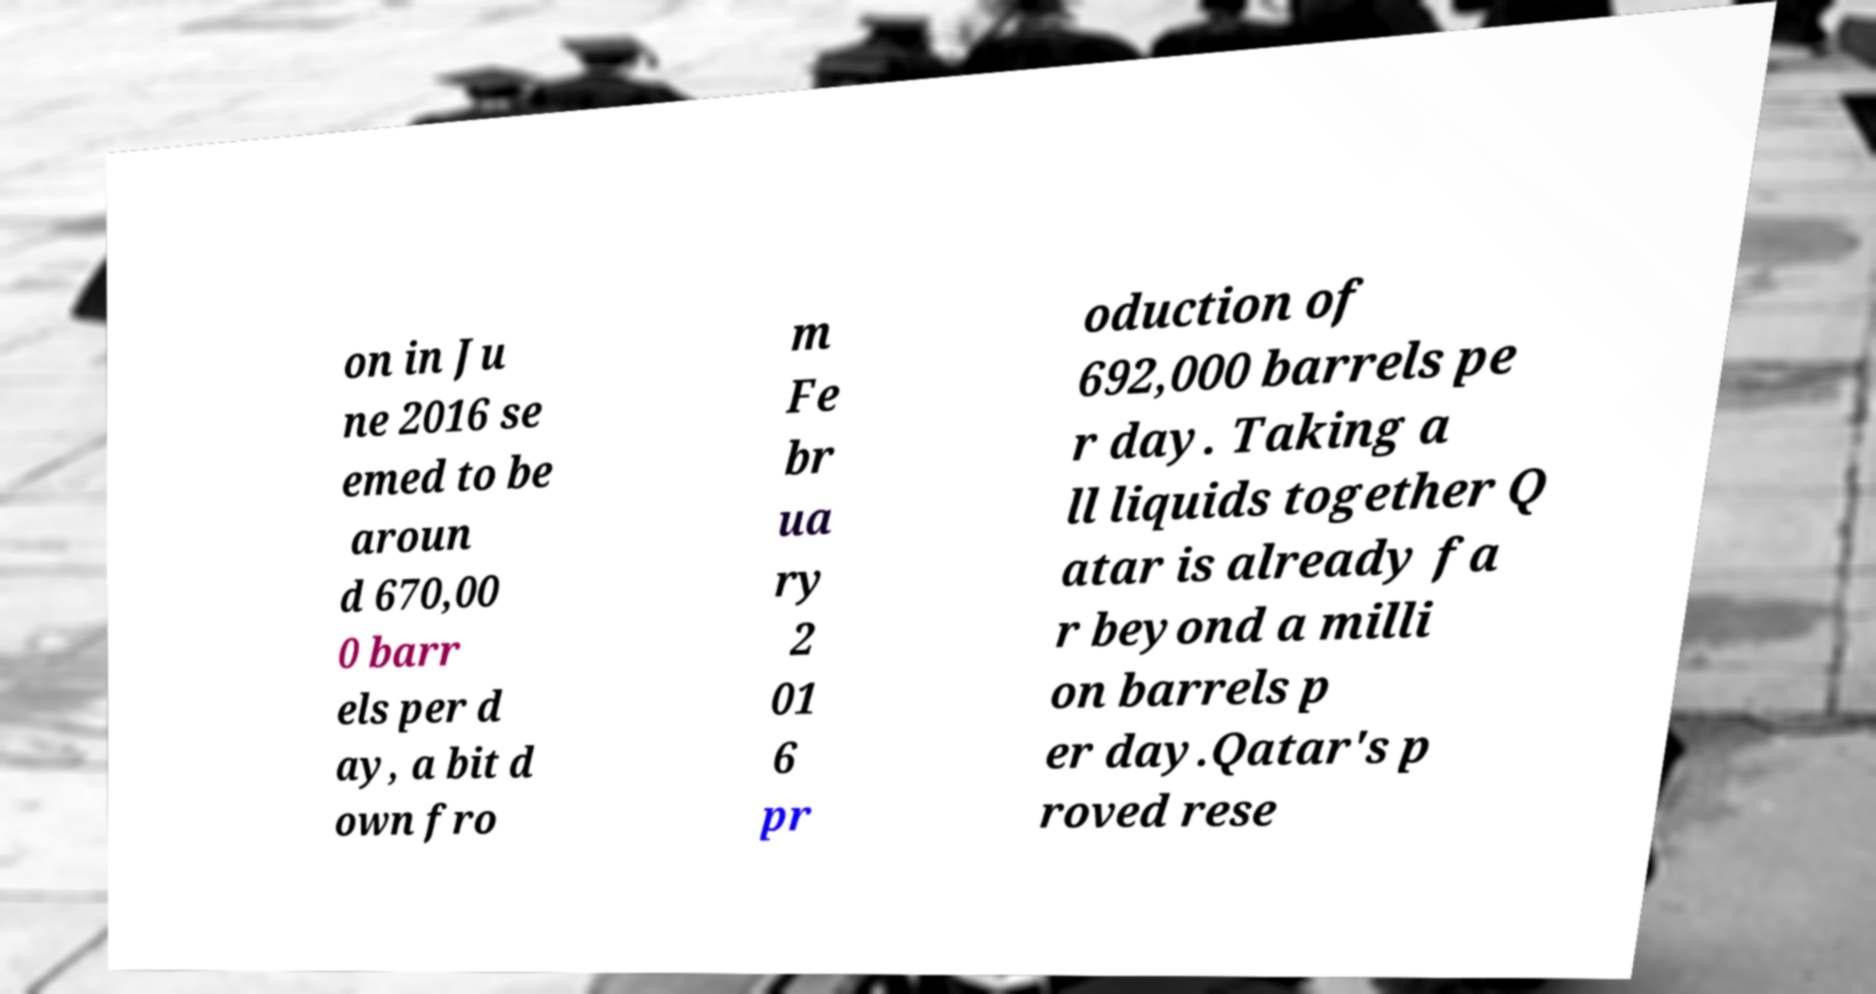Could you extract and type out the text from this image? on in Ju ne 2016 se emed to be aroun d 670,00 0 barr els per d ay, a bit d own fro m Fe br ua ry 2 01 6 pr oduction of 692,000 barrels pe r day. Taking a ll liquids together Q atar is already fa r beyond a milli on barrels p er day.Qatar's p roved rese 